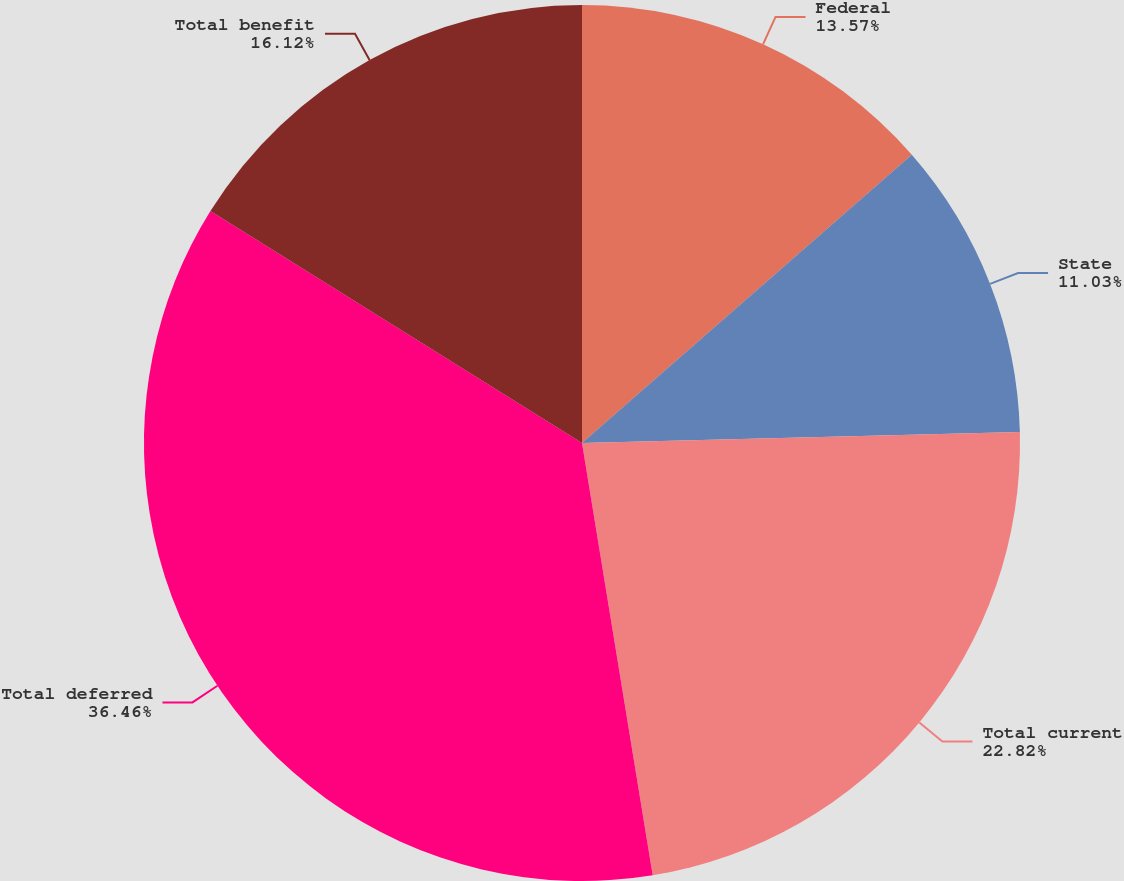<chart> <loc_0><loc_0><loc_500><loc_500><pie_chart><fcel>Federal<fcel>State<fcel>Total current<fcel>Total deferred<fcel>Total benefit<nl><fcel>13.57%<fcel>11.03%<fcel>22.82%<fcel>36.46%<fcel>16.12%<nl></chart> 